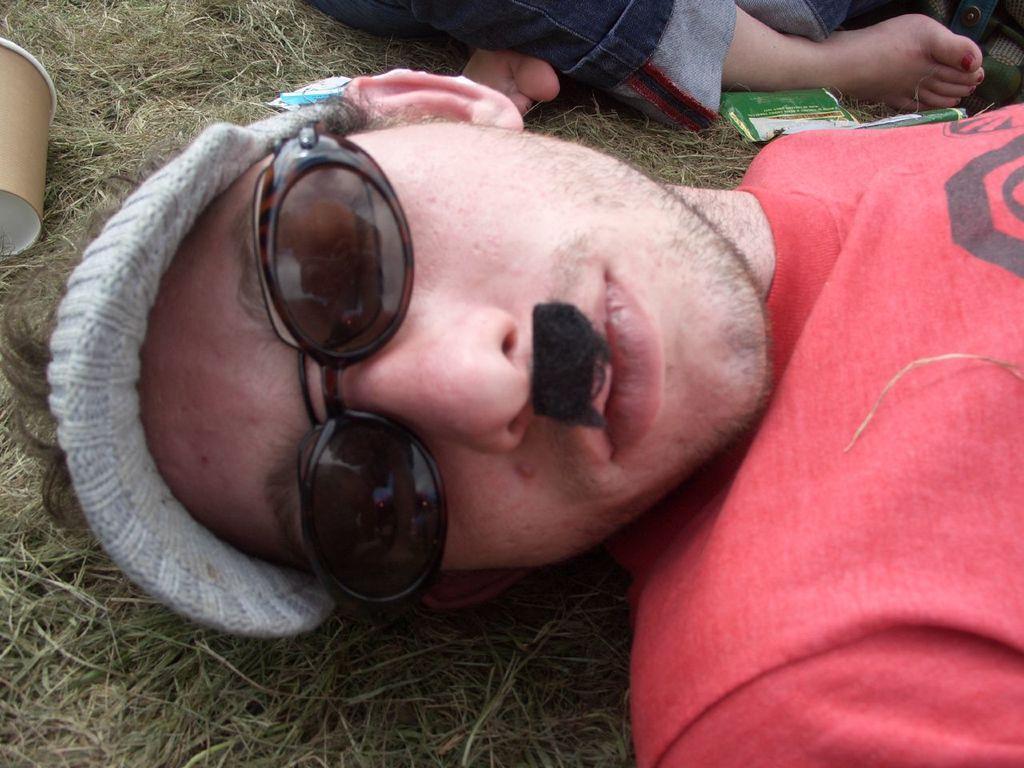Describe this image in one or two sentences. There is one man lying on a grassy land and wearing goggles and a cap in the middle of this image. There is a glass on the left side of this image, and there is one person sitting at the top of this image. 